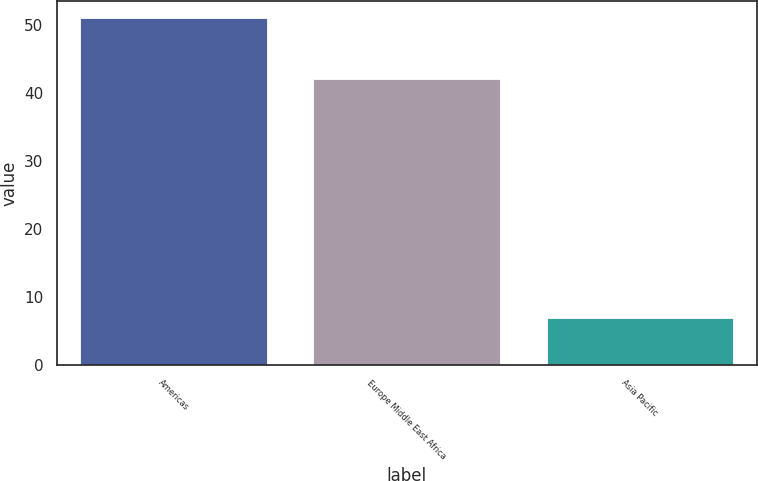Convert chart to OTSL. <chart><loc_0><loc_0><loc_500><loc_500><bar_chart><fcel>Americas<fcel>Europe Middle East Africa<fcel>Asia Pacific<nl><fcel>51<fcel>42<fcel>7<nl></chart> 